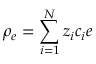Convert formula to latex. <formula><loc_0><loc_0><loc_500><loc_500>\rho _ { e } = \sum _ { i = 1 } ^ { N } z _ { i } c _ { i } e</formula> 